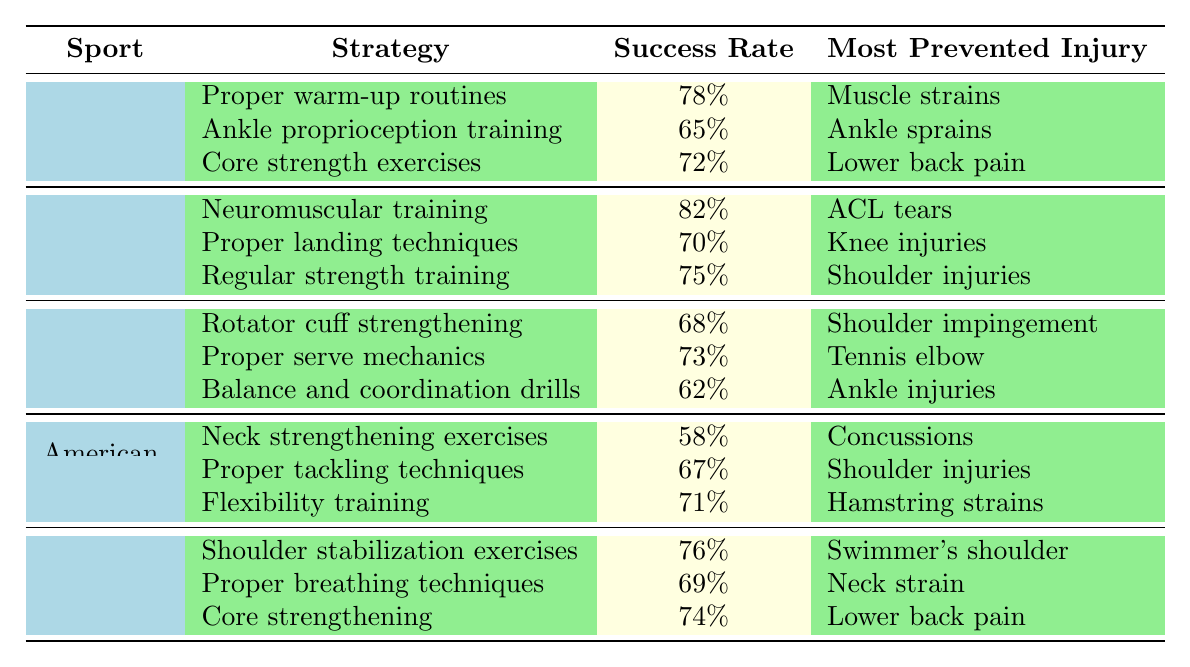What is the success rate of neuromuscular training in basketball? The table shows that the success rate for neuromuscular training under the basketball category is listed as 82%.
Answer: 82% Which strategy has the highest success rate in soccer? By examining the soccer strategies, proper warm-up routines have the highest success rate at 78%.
Answer: Proper warm-up routines What is the most prevented injury by core strength exercises in soccer? The table indicates that the most prevented injury by core strength exercises in soccer is lower back pain.
Answer: Lower back pain Is the success rate for proper landing techniques in basketball greater than 75%? According to the table, the success rate for proper landing techniques is 70%, which is less than 75%.
Answer: No Which sport has the lowest success rate for an injury prevention strategy? Looking through the table, American football's neck strengthening exercises have the lowest success rate at 58%.
Answer: American football What is the average success rate of injury prevention strategies in tennis? The success rates for tennis strategies are 68%, 73%, and 62%. Adding these gives a total of 203%, and dividing by 3 gives an average success rate of approximately 67.67%.
Answer: 67.67% What is the most common injury prevented by flexibility training in American football? Based on the table, flexibility training in American football primarily prevents hamstring strains.
Answer: Hamstring strains Which sport has the most effective injury prevention strategy based on success rate? Basketball's neuromuscular training has the highest success rate of 82%, making it the most effective strategy among the listed sports.
Answer: Basketball What injury is most commonly prevented by shoulder stabilization exercises in swimming? The table specifies that shoulder stabilization exercises in swimming prevent swimmer's shoulder.
Answer: Swimmer's shoulder Do both the proper breathing techniques and shoulder strengthening strategies in swimming have a success rate of over 70%? Proper breathing techniques have a success rate of 69% and shoulder stabilization exercises have a success rate of 76%, so not both exceed 70%.
Answer: No 